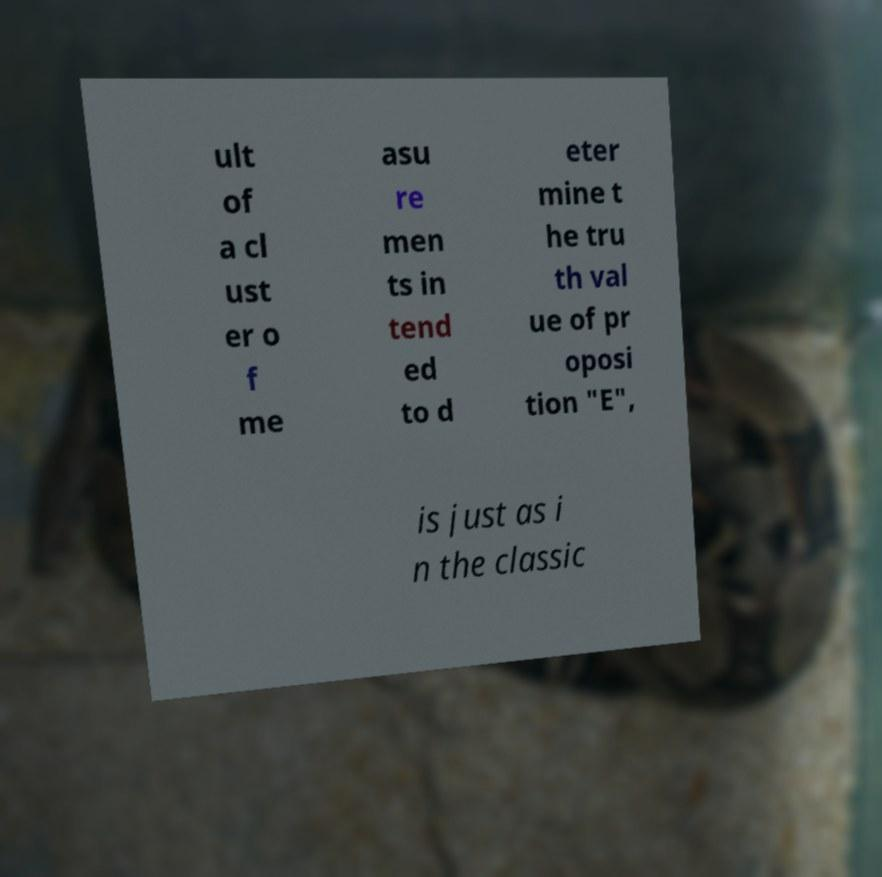For documentation purposes, I need the text within this image transcribed. Could you provide that? ult of a cl ust er o f me asu re men ts in tend ed to d eter mine t he tru th val ue of pr oposi tion "E", is just as i n the classic 